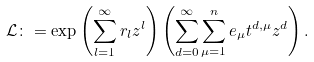Convert formula to latex. <formula><loc_0><loc_0><loc_500><loc_500>\mathcal { L } \colon = \exp \left ( \sum _ { l = 1 } ^ { \infty } r _ { l } z ^ { l } \right ) \left ( \sum _ { d = 0 } ^ { \infty } \sum _ { \mu = 1 } ^ { n } e _ { \mu } t ^ { d , \mu } z ^ { d } \right ) .</formula> 